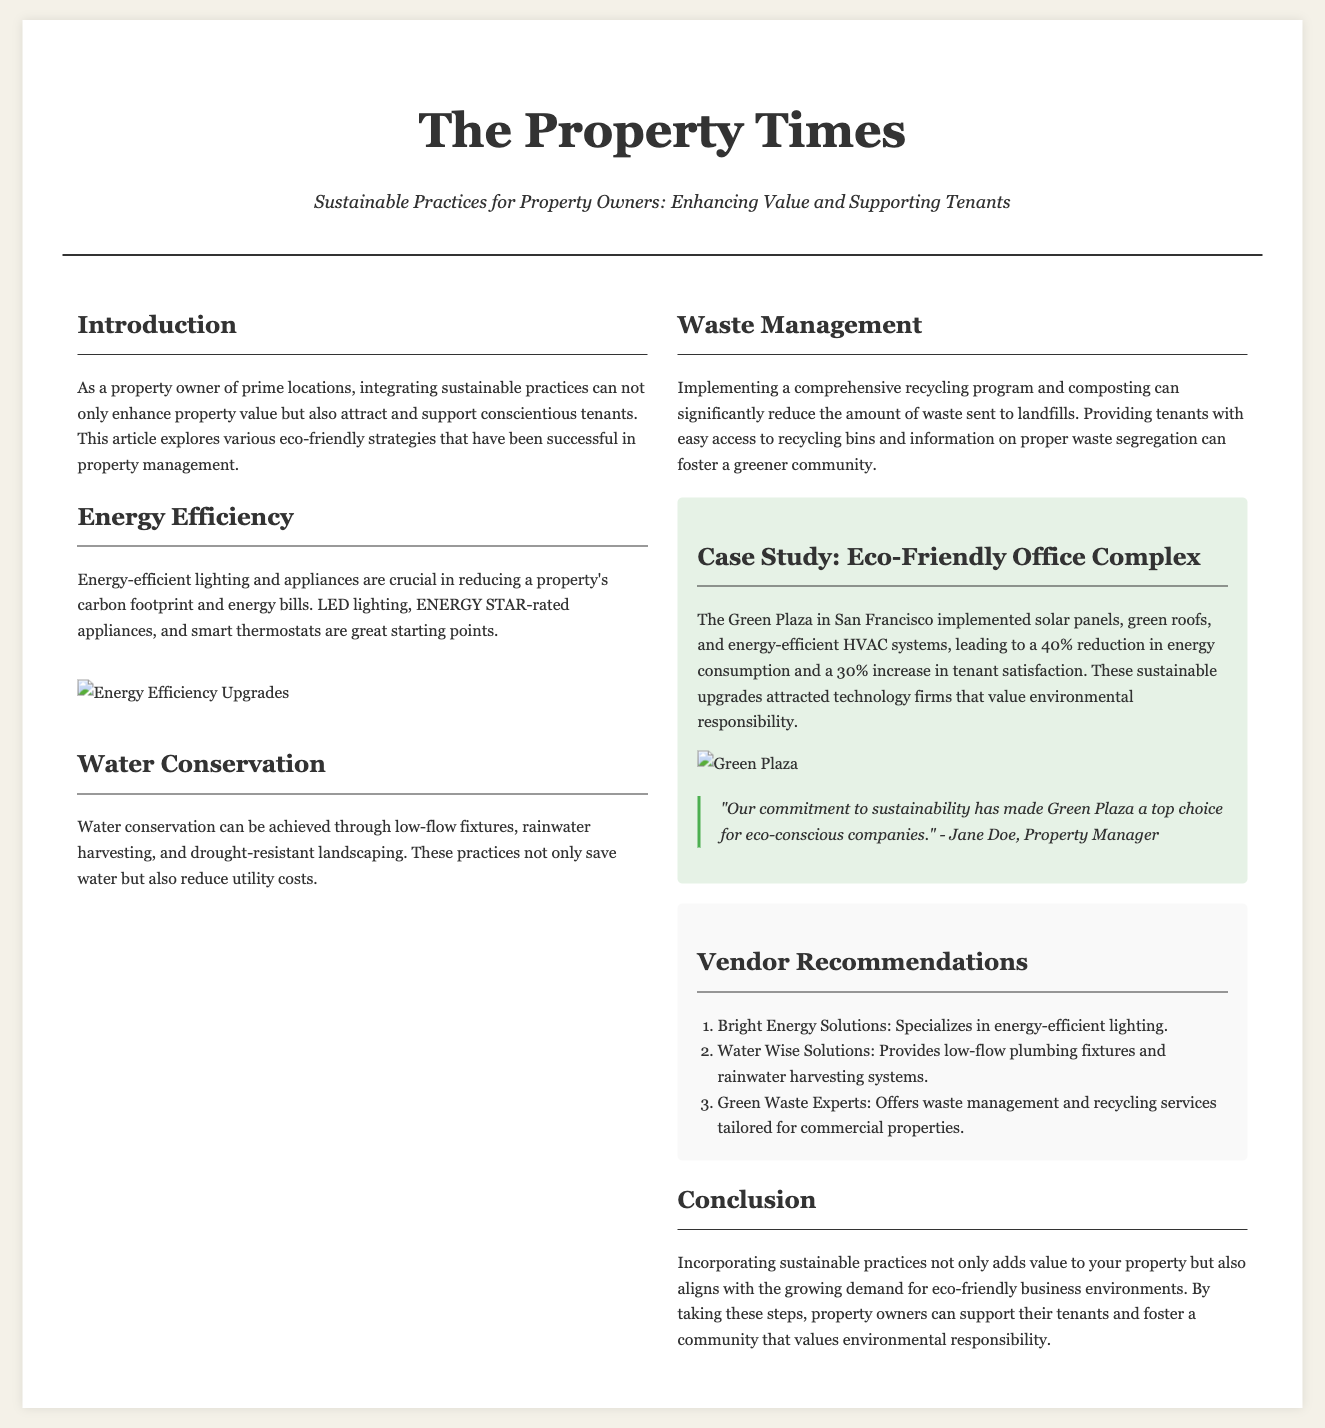What is the title of the article? The title of the article is stated at the top of the document, which is "Sustainable Practices for Property Owners: Enhancing Value and Supporting Tenants."
Answer: Sustainable Practices for Property Owners: Enhancing Value and Supporting Tenants How much reduction in energy consumption did the Green Plaza achieve? The percentage of reduction in energy consumption is mentioned in the case study section of the document, which states a 40% reduction.
Answer: 40% What type of lighting is recommended for energy efficiency? The document recommends using energy-efficient lighting, specifically mentioning LED lighting.
Answer: LED lighting Which vendor specializes in low-flow plumbing fixtures? In the vendor recommendations section, it specifies that Water Wise Solutions provides low-flow plumbing fixtures.
Answer: Water Wise Solutions What is one eco-friendly strategy mentioned for water conservation? The document lists several strategies for water conservation, one of which is using low-flow fixtures.
Answer: Low-flow fixtures How much increase in tenant satisfaction did the Green Plaza experience? The document includes a statistic about tenant satisfaction increase in the case study section, which states a 30% increase.
Answer: 30% What is the color scheme of the document's background? The background color for the body of the document is specified as #f4f1e8, described as light beige.
Answer: Light beige What type of practice is highlighted in the introduction as beneficial for property owners? The introduction emphasizes the integration of sustainable practices as beneficial for enhancing property value and attracting tenants.
Answer: Sustainable practices 